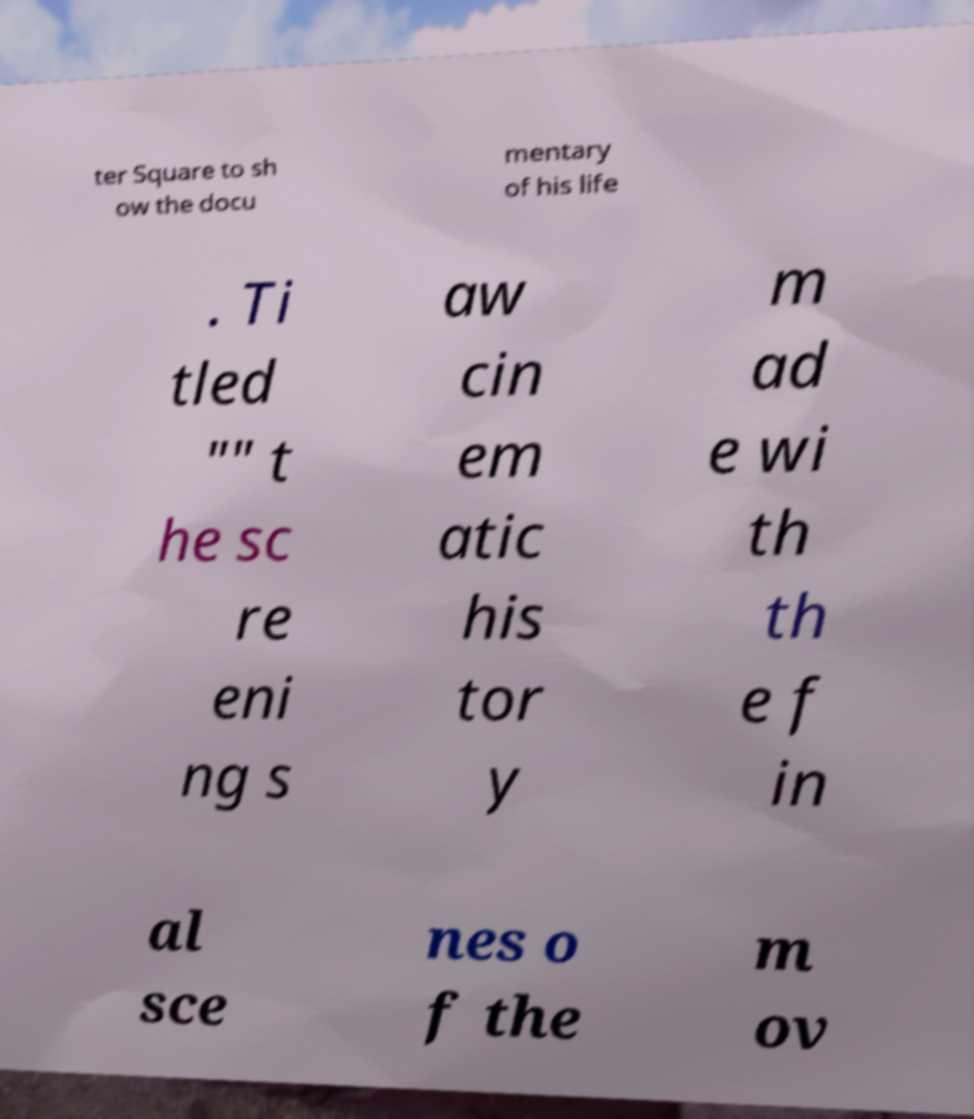I need the written content from this picture converted into text. Can you do that? ter Square to sh ow the docu mentary of his life . Ti tled "" t he sc re eni ng s aw cin em atic his tor y m ad e wi th th e f in al sce nes o f the m ov 